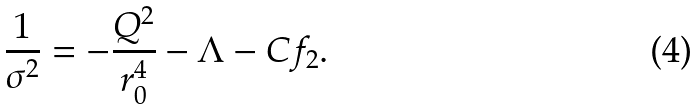Convert formula to latex. <formula><loc_0><loc_0><loc_500><loc_500>\frac { 1 } { \sigma ^ { 2 } } = - \frac { Q ^ { 2 } } { r _ { 0 } ^ { 4 } } - \Lambda - C f _ { 2 } \text {.}</formula> 